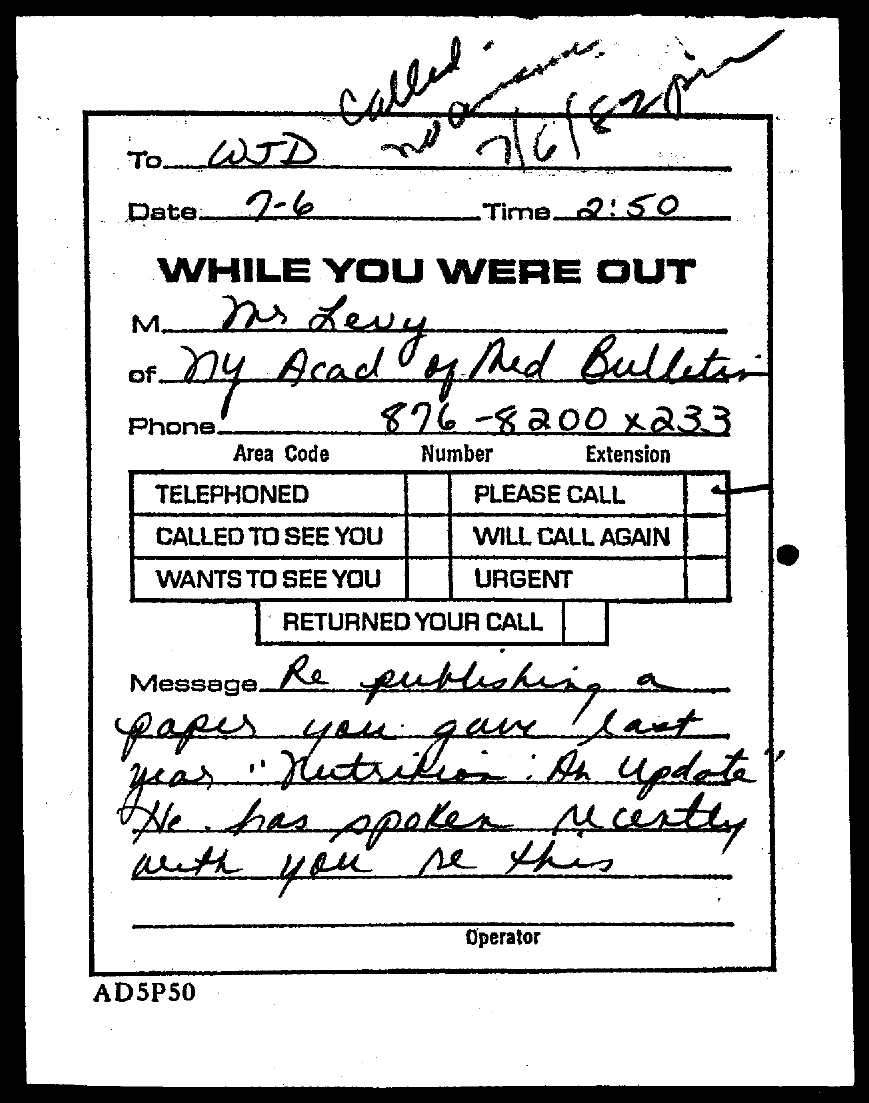Give some essential details in this illustration. The date mentioned in the document is 7-6.. The document mentions a time of 2:50. 